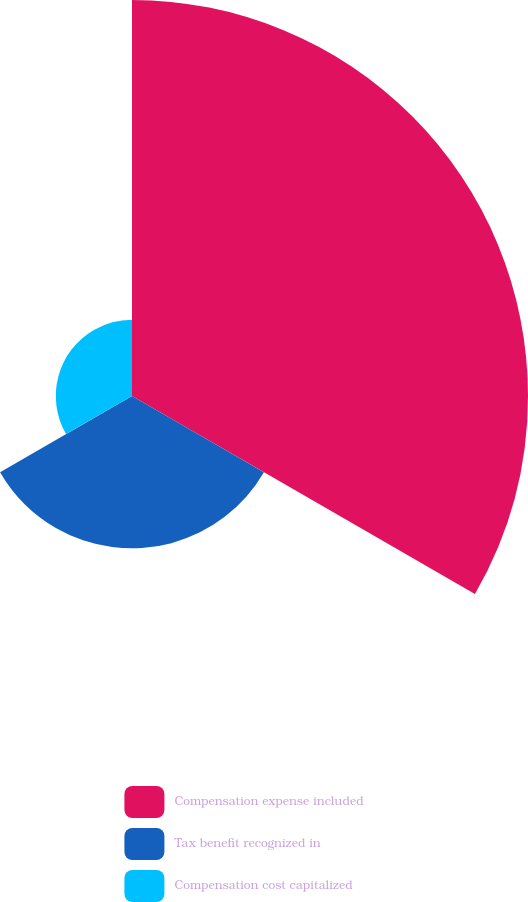Convert chart. <chart><loc_0><loc_0><loc_500><loc_500><pie_chart><fcel>Compensation expense included<fcel>Tax benefit recognized in<fcel>Compensation cost capitalized<nl><fcel>63.41%<fcel>24.39%<fcel>12.2%<nl></chart> 